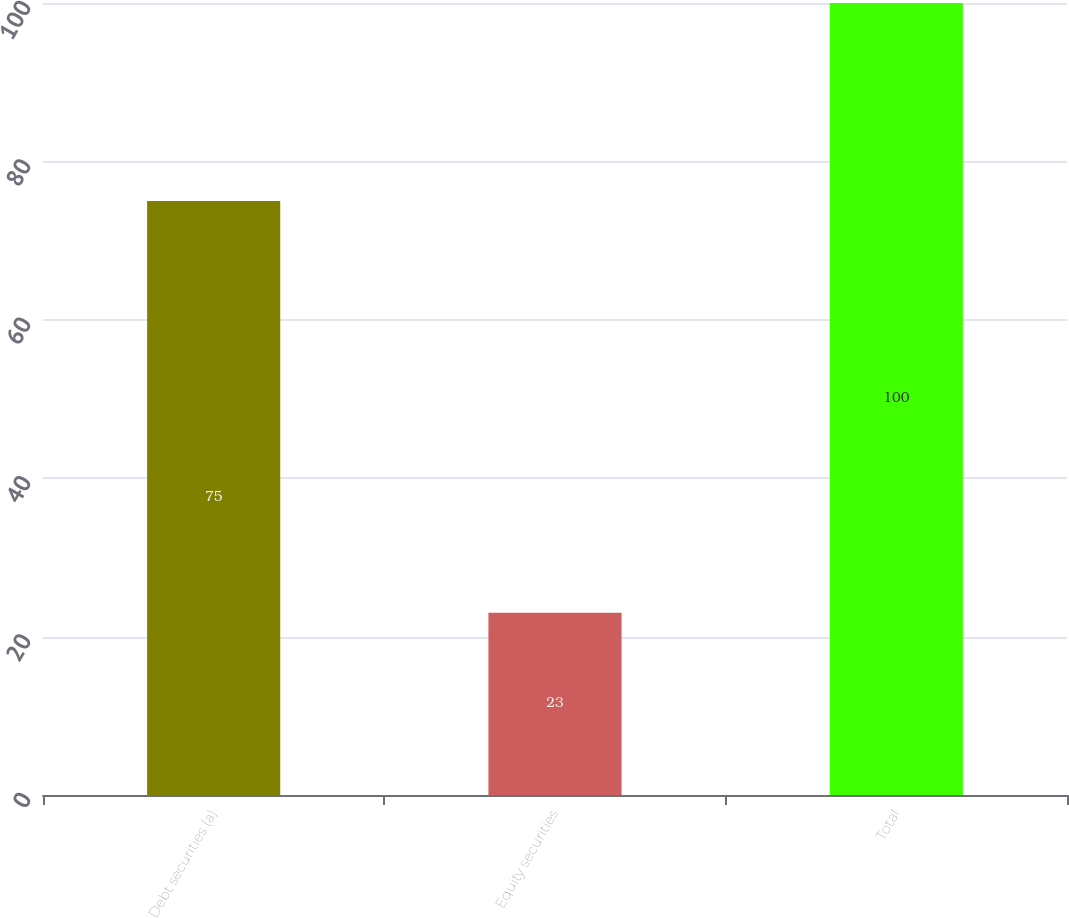Convert chart. <chart><loc_0><loc_0><loc_500><loc_500><bar_chart><fcel>Debt securities (a)<fcel>Equity securities<fcel>Total<nl><fcel>75<fcel>23<fcel>100<nl></chart> 